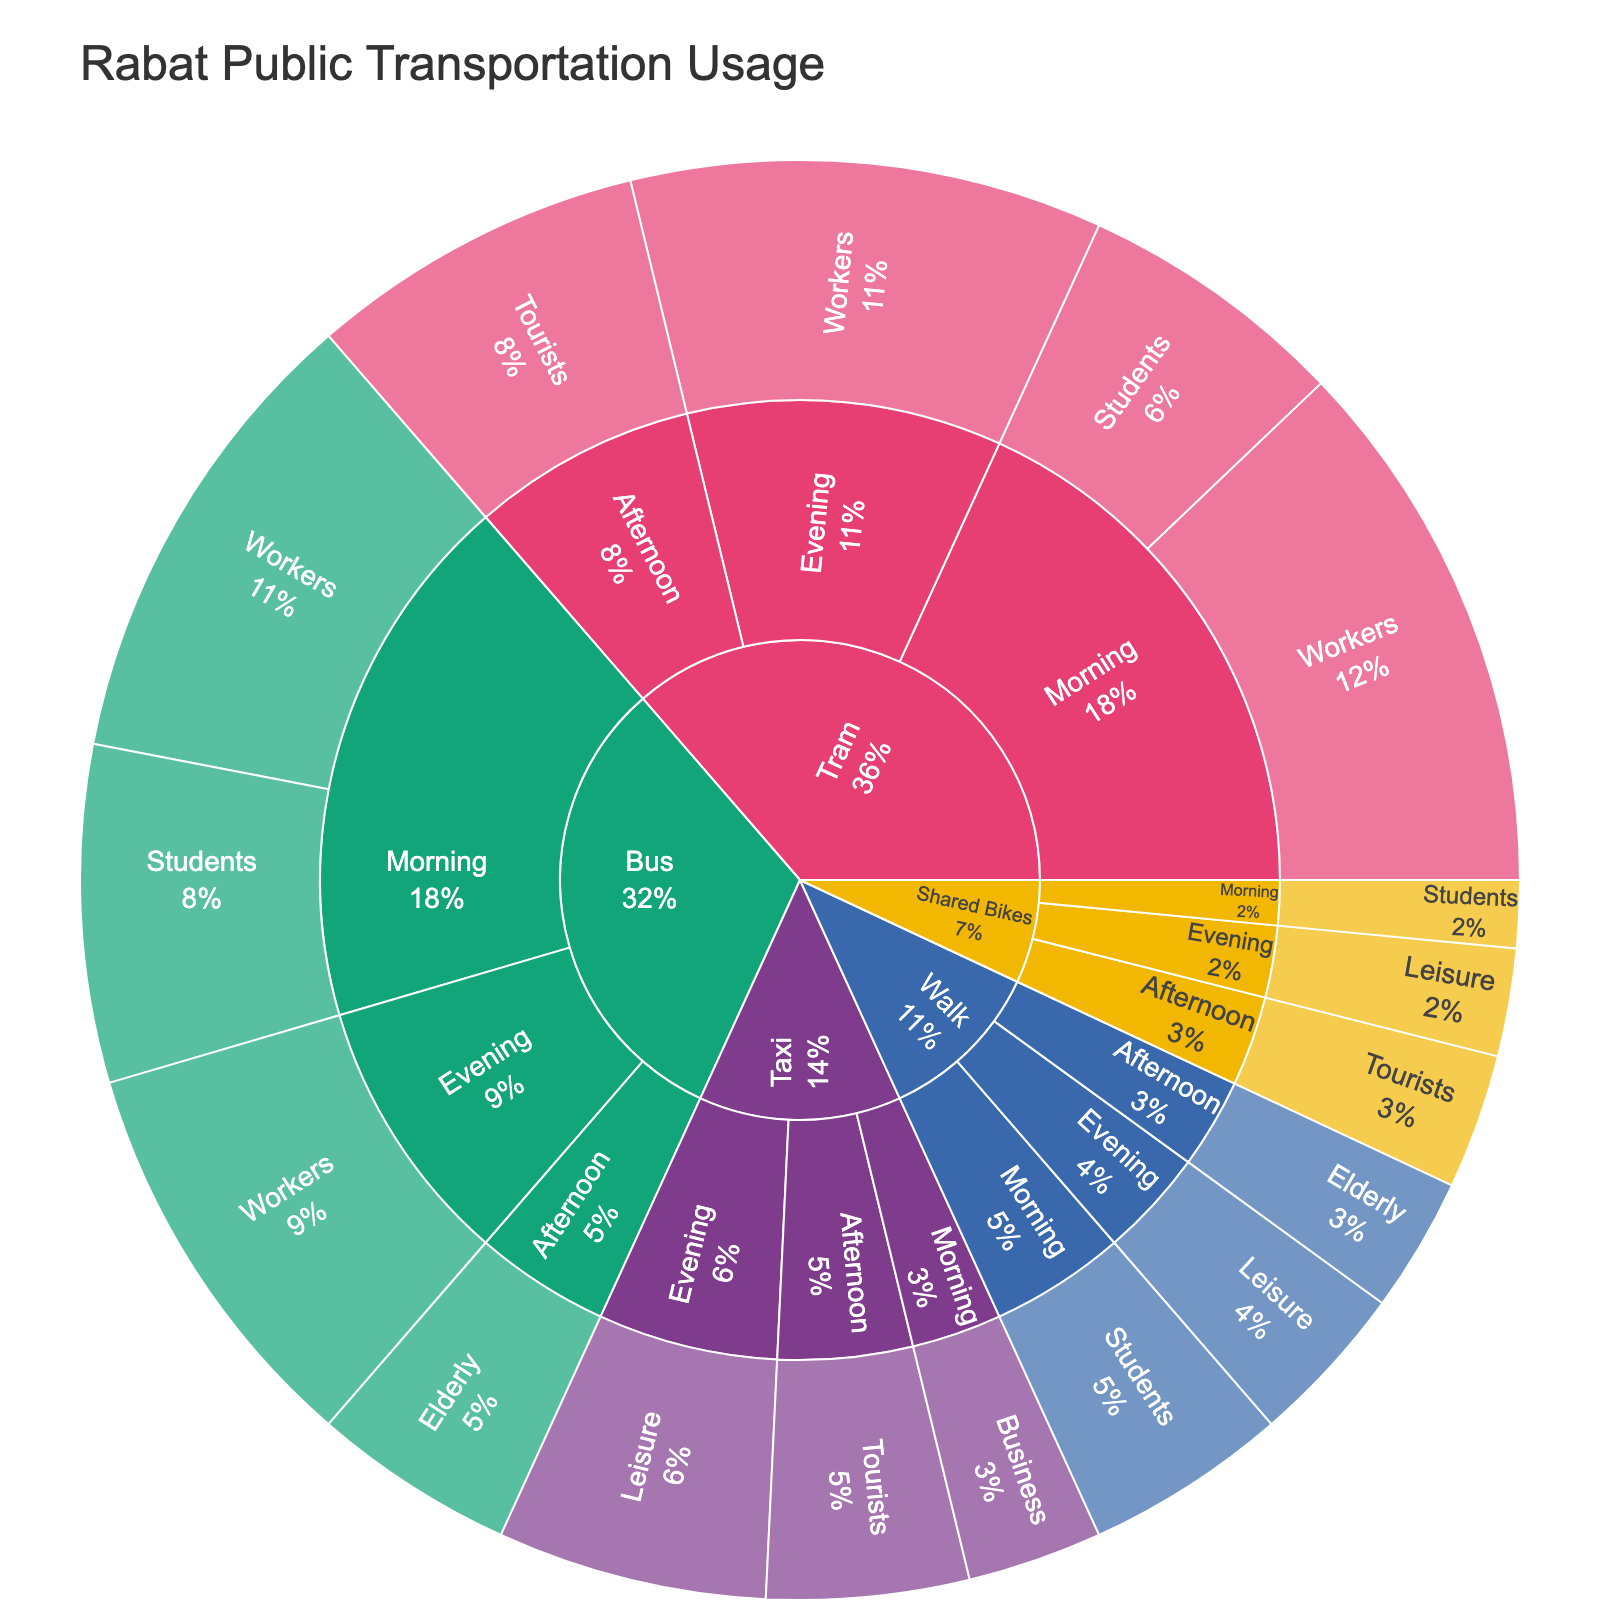what's the title of the plot? The title is typically located at the top of the plot. In this case, it states "Rabat Public Transportation Usage".
Answer: Rabat Public Transportation Usage What percentage of public transportation users are workers using buses in the evening? Workers using buses in the evening would be a sub-group under "Bus -> Evening -> Workers". The percentage can be read directly from the plot at this specific segment.
Answer: 30% How many users take trams in the morning? Look for the segments under "Tram -> Morning". The usage values for students and workers are 20 and 40 respectively, leading to a total. 20 + 40 = 60.
Answer: 60 Which demographic has the least usage in any time of day for shared bikes? Identify the usage segments under "Shared Bikes" for each demographic. Compare the values and find the smallest one.
Answer: Students in the morning What is the difference in usage between taxis and buses in the afternoon? Identify the afternoon segments for each mode. Summarize the usage values, and subtract the values of taxis from buses. Buses have 15 usage, taxis have 15, so 15 - 15 = 0.
Answer: 0 Which mode of transportation is least utilized in the evening? Compare the usage values of all modes during the evening. Identify the one with the smallest value. Shared Bikes have 8, which is the least among others.
Answer: Shared Bikes How does the morning tram usage compare to the evening tram usage? Identify and compare the segments under "Tram -> Morning" and "Tram -> Evening". The morning usage is 20 (students) + 40 (workers) = 60, and the evening usage is 35 (workers). Morning usage is higher than evening usage.
Answer: Morning usage is higher What percentage of total bus users are students? First, calculate the total usage of buses by summing up all segments (25 + 35 + 15 + 30 = 105). Then, calculate the percentage of students in this total. (25 / 105) * 100 ≈ 23.81%.
Answer: ~23.81% Which time of day has the highest usage for walking? Compare segments under "Walk" for morning, afternoon, and evening. The morning has 15, afternoon has 10, and evening has 12. Morning has the highest usage.
Answer: Morning Which demographic uses taxis for business purposes? Looking at the taxi segments, identify the demographic listed under "Taxi -> Morning -> Business".
Answer: Business 